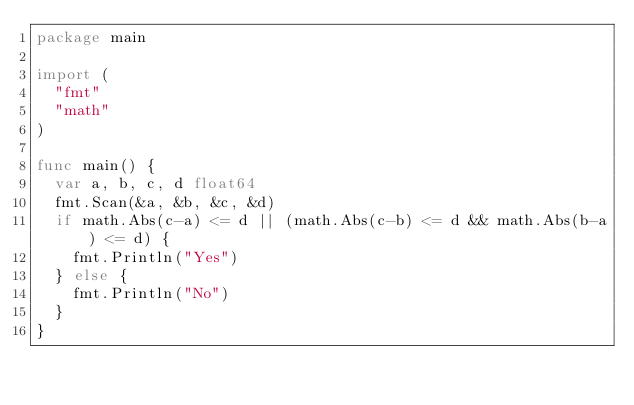<code> <loc_0><loc_0><loc_500><loc_500><_Go_>package main

import (
	"fmt"
	"math"
)

func main() {
	var a, b, c, d float64
	fmt.Scan(&a, &b, &c, &d)
	if math.Abs(c-a) <= d || (math.Abs(c-b) <= d && math.Abs(b-a) <= d) {
		fmt.Println("Yes")
	} else {
		fmt.Println("No")
	}
}
</code> 